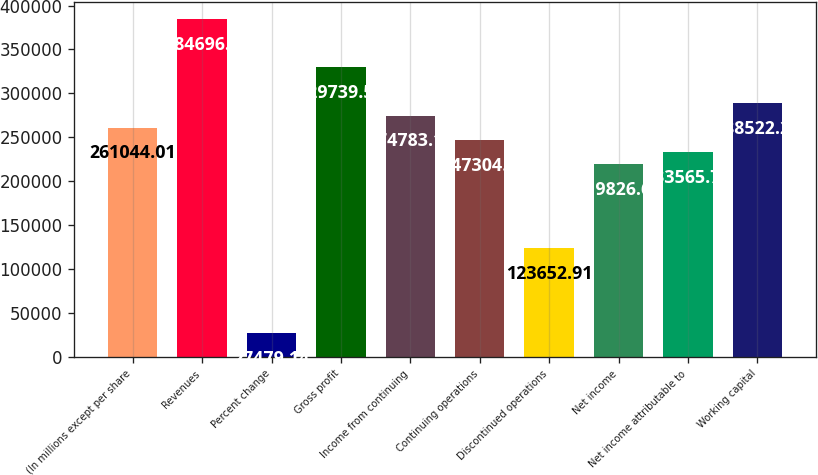Convert chart to OTSL. <chart><loc_0><loc_0><loc_500><loc_500><bar_chart><fcel>(In millions except per share<fcel>Revenues<fcel>Percent change<fcel>Gross profit<fcel>Income from continuing<fcel>Continuing operations<fcel>Discontinued operations<fcel>Net income<fcel>Net income attributable to<fcel>Working capital<nl><fcel>261044<fcel>384696<fcel>27479.1<fcel>329740<fcel>274783<fcel>247305<fcel>123653<fcel>219827<fcel>233566<fcel>288522<nl></chart> 